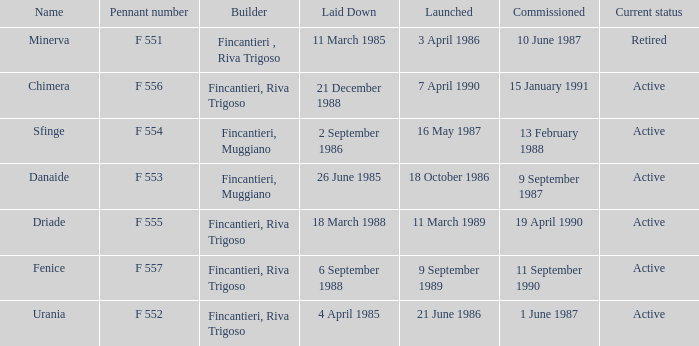Which launch date involved the Driade? 11 March 1989. 